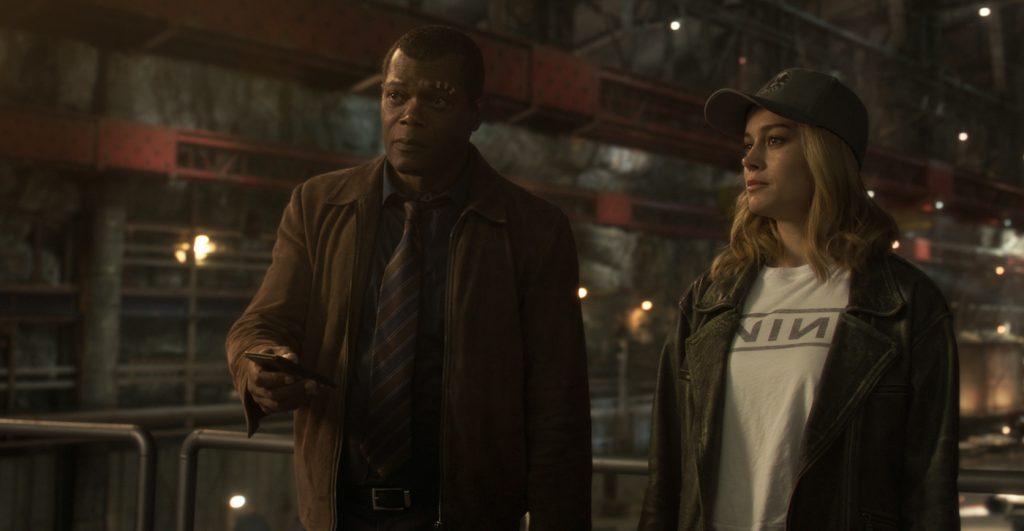Provide more context about the setting of this image in the movie. This scene occurs in an underground facility that plays a significant role in 'Captain Marvel.' The industrial and dimly lit environment, with its red pipes and metal railings, adds to the tension and secrecy typical of such locations. In the story, this facility is where key plot developments unfold that are crucial to the characters' mission, contributing to the suspense and dramatic elements of the movie. What do you think Nick Fury and Carol Danvers are discussing? Based on their serious expressions and the setting, it is likely that Nick Fury and Carol Danvers are discussing a critical part of their mission. They could be formulating a plan to counter a major threat or trying to uncover important information that could turn the tide in their favor. The presence of a phone suggests they might be awaiting or receiving vital intelligence at this moment. Imagine an alternate scenario where they are in a comedy movie setting. What might be happening? In an alternate comedic universe, Nick Fury and Carol Danvers might be standing in a quirky, brightly lit factory filled with amusing gadgets and humorous background figures. Instead of holding a phone to receive serious intel, Nick Fury could be holding a banana oddly mistaken for a phone, causing Carol to stifle a laugh. Their 'serious' expressions could be a result of trying to keep a straight face in a ridiculously funny situation, perhaps after a hilarious misunderstanding or after something comically unexpected happened. Now, create a very imaginative scenario involving both characters in this setting that has a sci-fi twist. In an imaginative sci-fi twist, Nick Fury and Carol Danvers find themselves in a sprawling interdimensional port. The red pipes and industrial design are parts of a massive time machine powered by exotic energy sources. As they stand, they are aware that the device is the key to preventing an intergalactic war. At that moment, Fury's phone isn't just for communication—it’s a device that controls the machine’s temporal settings. The serious looks on their faces reflect the gravity of their mission: to navigate through time and space, aligning with unique celestial events to prevent a collapse of the multiverse. Their surroundings flicker with energy, hinting at the latent power and imminent adventure lying ahead. 